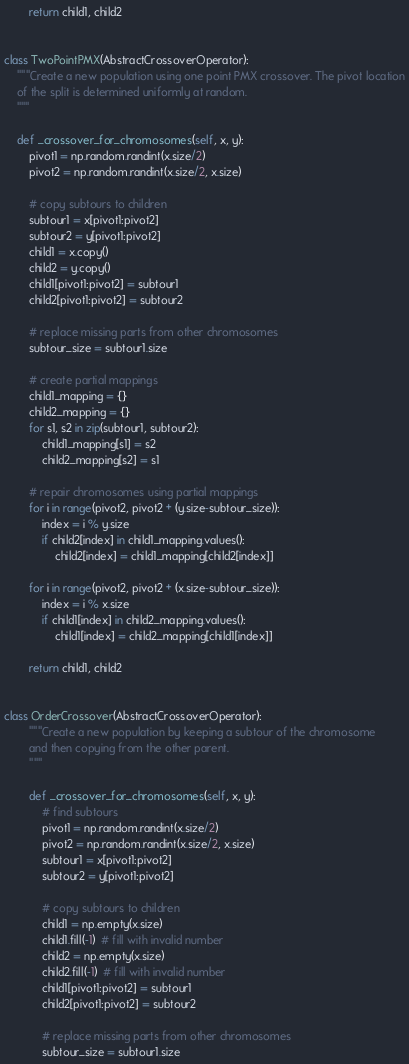Convert code to text. <code><loc_0><loc_0><loc_500><loc_500><_Python_>
        return child1, child2


class TwoPointPMX(AbstractCrossoverOperator):
    """Create a new population using one point PMX crossover. The pivot location
    of the split is determined uniformly at random.
    """

    def _crossover_for_chromosomes(self, x, y):
        pivot1 = np.random.randint(x.size/2)
        pivot2 = np.random.randint(x.size/2, x.size)

        # copy subtours to children
        subtour1 = x[pivot1:pivot2]
        subtour2 = y[pivot1:pivot2]
        child1 = x.copy()
        child2 = y.copy()
        child1[pivot1:pivot2] = subtour1
        child2[pivot1:pivot2] = subtour2

        # replace missing parts from other chromosomes
        subtour_size = subtour1.size

        # create partial mappings
        child1_mapping = {}
        child2_mapping = {}
        for s1, s2 in zip(subtour1, subtour2):
            child1_mapping[s1] = s2
            child2_mapping[s2] = s1

        # repair chromosomes using partial mappings
        for i in range(pivot2, pivot2 + (y.size-subtour_size)):
            index = i % y.size
            if child2[index] in child1_mapping.values():
                child2[index] = child1_mapping[child2[index]]

        for i in range(pivot2, pivot2 + (x.size-subtour_size)):
            index = i % x.size
            if child1[index] in child2_mapping.values():
                child1[index] = child2_mapping[child1[index]]

        return child1, child2


class OrderCrossover(AbstractCrossoverOperator):
        """Create a new population by keeping a subtour of the chromosome
        and then copying from the other parent.
        """

        def _crossover_for_chromosomes(self, x, y):
            # find subtours
            pivot1 = np.random.randint(x.size/2)
            pivot2 = np.random.randint(x.size/2, x.size)
            subtour1 = x[pivot1:pivot2]
            subtour2 = y[pivot1:pivot2]

            # copy subtours to children
            child1 = np.empty(x.size)
            child1.fill(-1)  # fill with invalid number
            child2 = np.empty(x.size)
            child2.fill(-1)  # fill with invalid number
            child1[pivot1:pivot2] = subtour1
            child2[pivot1:pivot2] = subtour2

            # replace missing parts from other chromosomes
            subtour_size = subtour1.size
</code> 